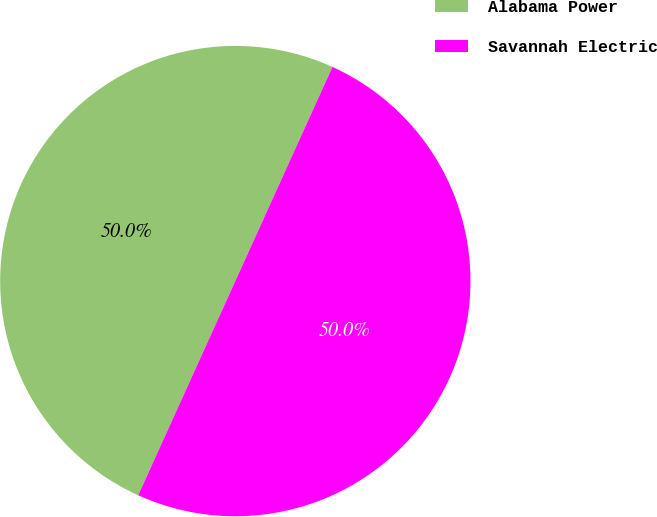<chart> <loc_0><loc_0><loc_500><loc_500><pie_chart><fcel>Alabama Power<fcel>Savannah Electric<nl><fcel>50.0%<fcel>50.0%<nl></chart> 